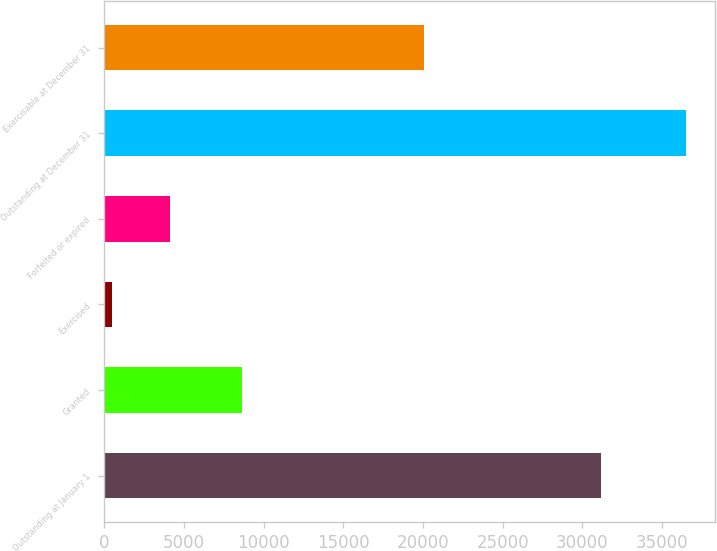<chart> <loc_0><loc_0><loc_500><loc_500><bar_chart><fcel>Outstanding at January 1<fcel>Granted<fcel>Exercised<fcel>Forfeited or expired<fcel>Outstanding at December 31<fcel>Exercisable at December 31<nl><fcel>31152<fcel>8633<fcel>521<fcel>4119.1<fcel>36502<fcel>20070<nl></chart> 